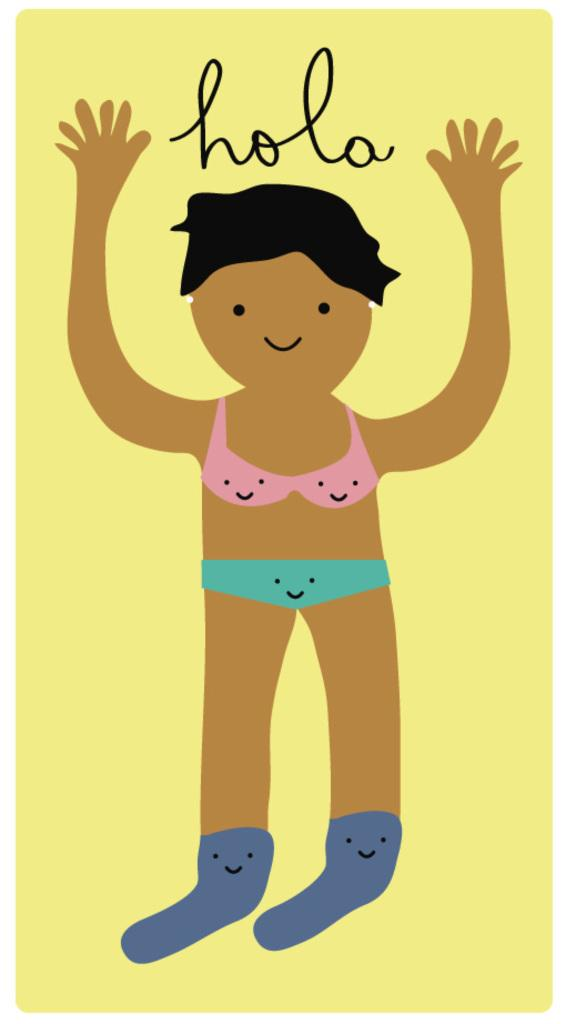What type of picture is in the image? The image contains an animated picture. Can you describe the animated picture? There is a person in the animated picture. What is written at the top of the image? There is text written at the top of the image. What type of box is being used to care for the jam in the image? There is no box or jam present in the image; it only contains an animated picture with a person and text at the top. 